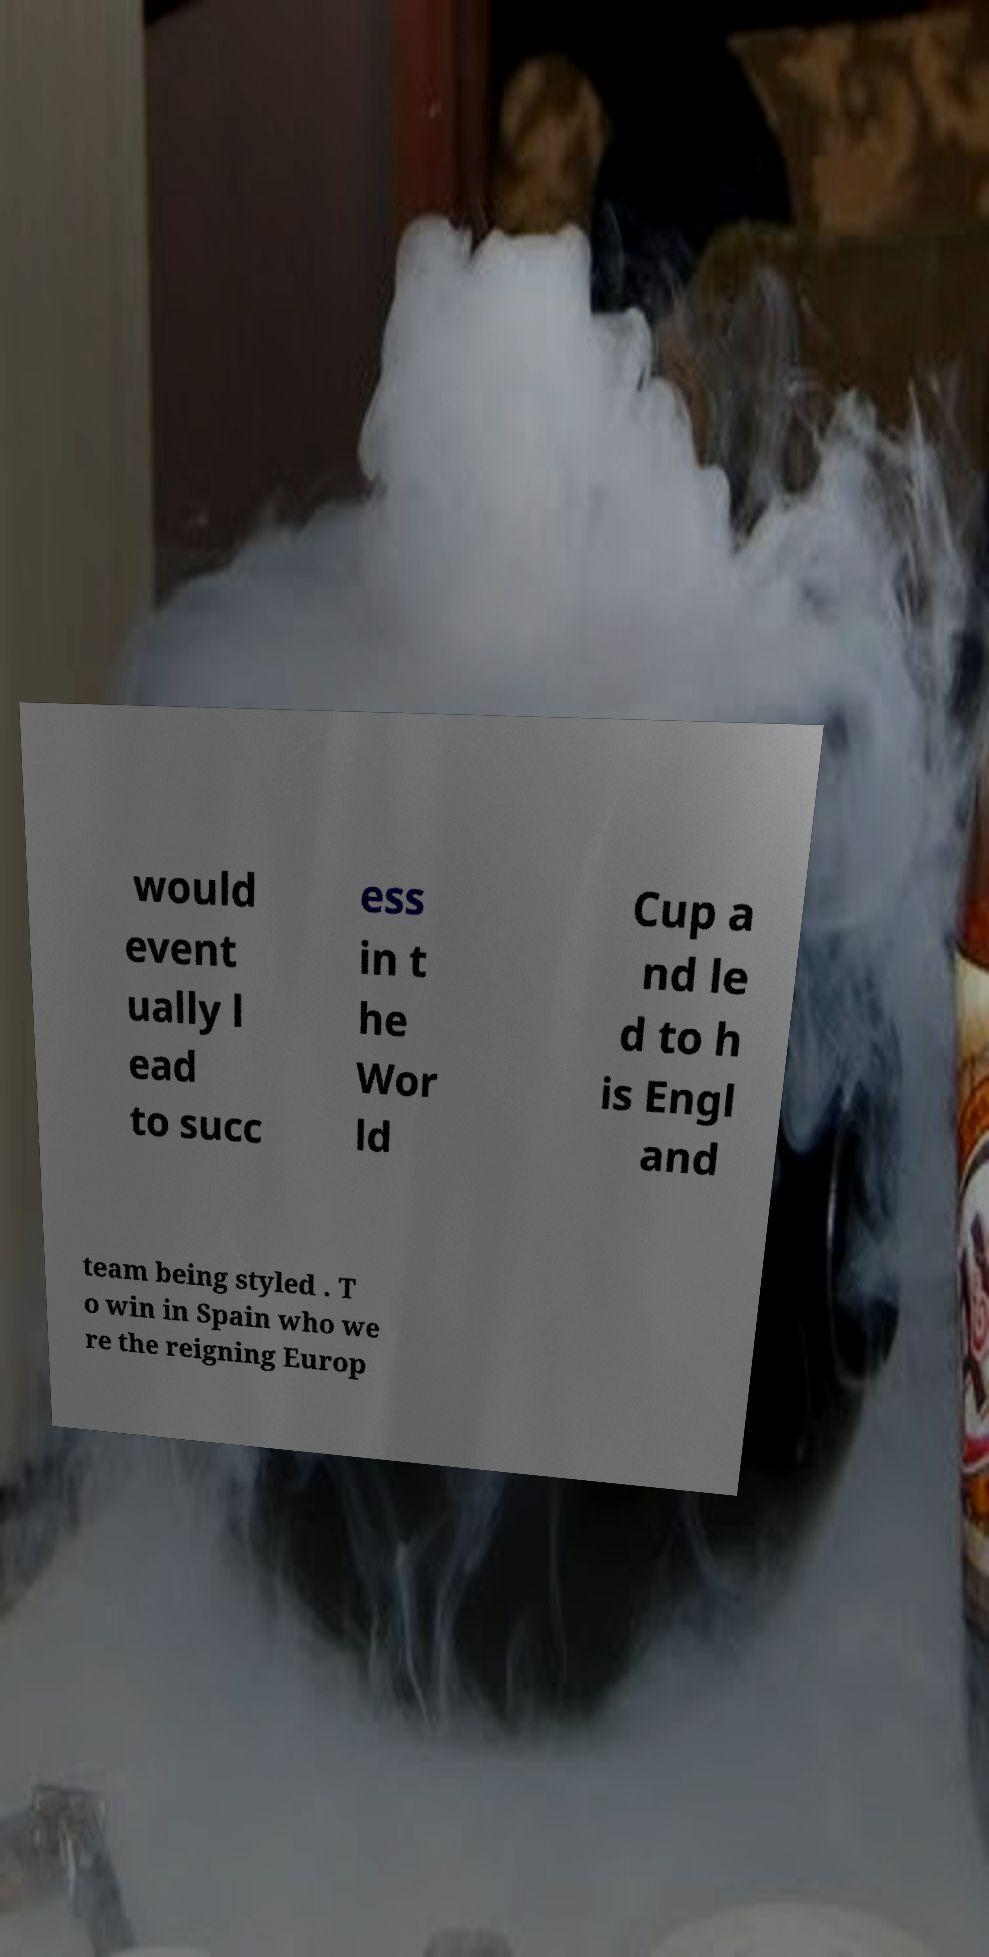I need the written content from this picture converted into text. Can you do that? would event ually l ead to succ ess in t he Wor ld Cup a nd le d to h is Engl and team being styled . T o win in Spain who we re the reigning Europ 